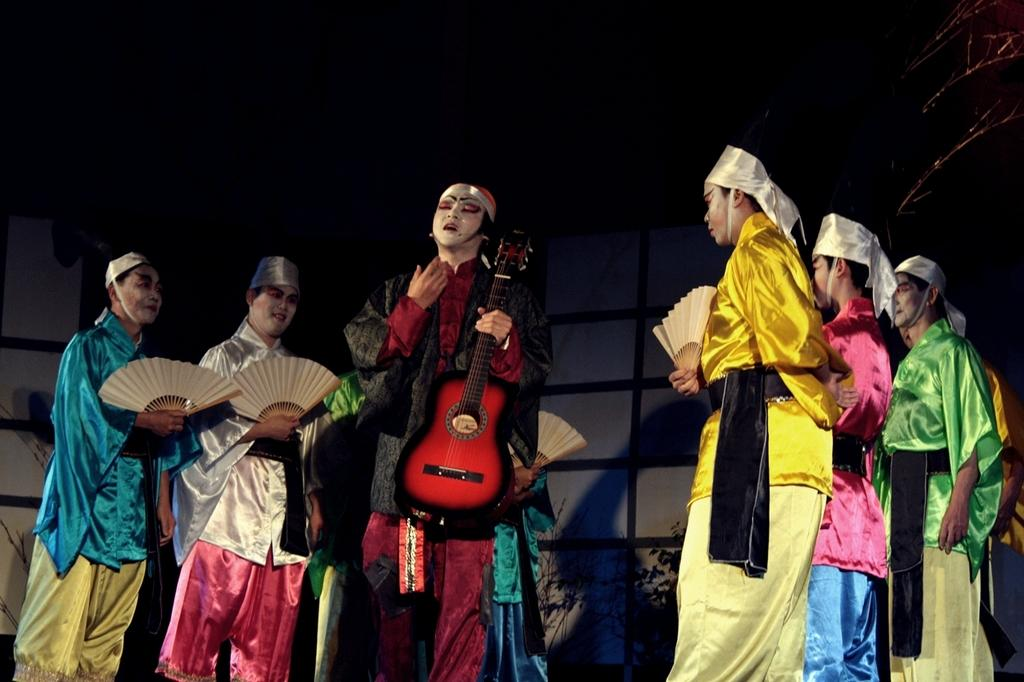What can be observed about the people in the image? There are people in the image, and they are wearing costumes. Can you describe any specific accessories or instruments the people are holding? One person is holding a guitar, while other people are holding hand fans. What type of headwear are the people wearing? All the people are wearing caps. Can you tell me how many bananas are being used as a kettle in the image? There are no bananas or kettles present in the image. 